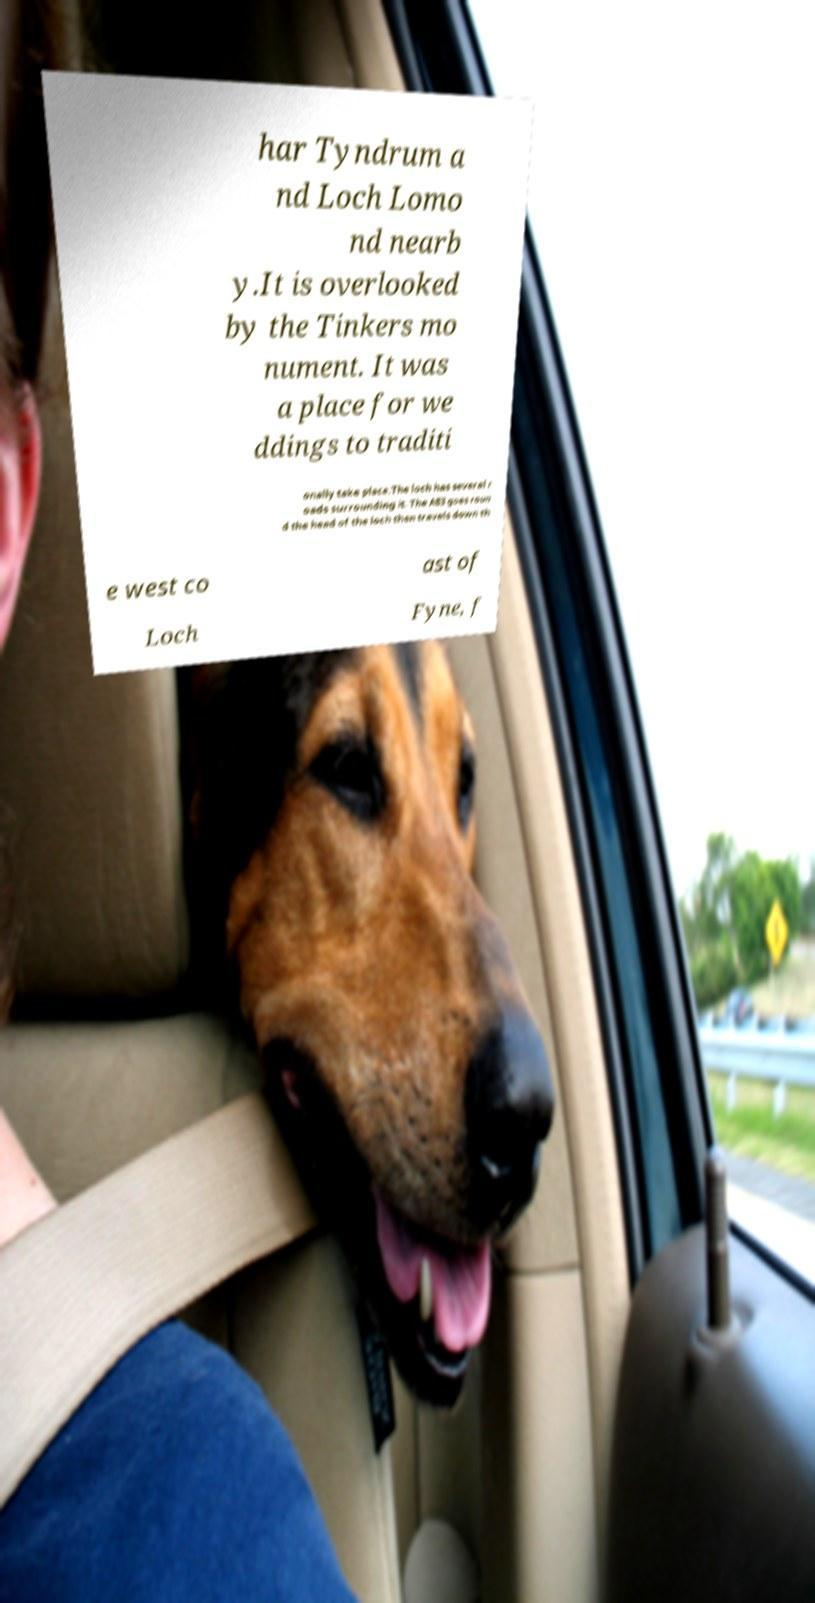Can you read and provide the text displayed in the image?This photo seems to have some interesting text. Can you extract and type it out for me? har Tyndrum a nd Loch Lomo nd nearb y.It is overlooked by the Tinkers mo nument. It was a place for we ddings to traditi onally take place.The loch has several r oads surrounding it. The A83 goes roun d the head of the loch then travels down th e west co ast of Loch Fyne, f 